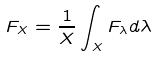Convert formula to latex. <formula><loc_0><loc_0><loc_500><loc_500>F _ { X } = \frac { 1 } { X } \int _ { X } F _ { \lambda } d \lambda</formula> 